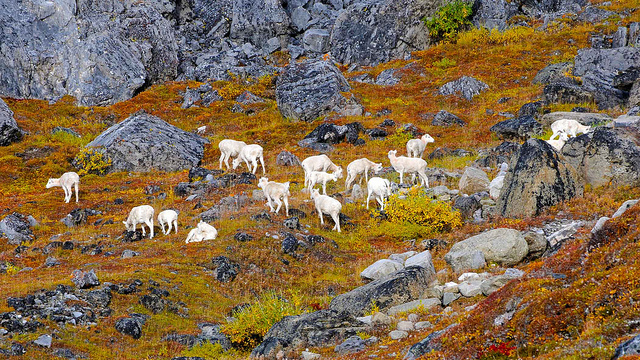What type of environment are the animals in? The animals are in a mountainous terrain characterized by rocky outcrops and a spattering of colorful vegetation, suggesting it's either late summer or autumn when the flora begins to change. 